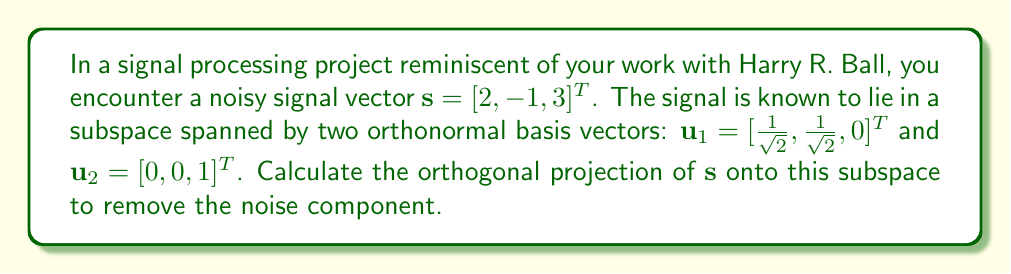Can you solve this math problem? To calculate the orthogonal projection of $\mathbf{s}$ onto the subspace spanned by $\mathbf{u}_1$ and $\mathbf{u}_2$, we'll follow these steps:

1) The projection matrix onto the subspace is given by:
   $$P = U(U^TU)^{-1}U^T$$
   where $U = [\mathbf{u}_1 \quad \mathbf{u}_2]$

2) Construct matrix $U$:
   $$U = \begin{bmatrix} 
   \frac{1}{\sqrt{2}} & 0 \\
   \frac{1}{\sqrt{2}} & 0 \\
   0 & 1
   \end{bmatrix}$$

3) Calculate $U^TU$:
   $$U^TU = \begin{bmatrix} 
   1 & 0 \\
   0 & 1
   \end{bmatrix}$$

4) As $U^TU$ is already the identity matrix, $(U^TU)^{-1} = I$

5) Calculate the projection matrix $P$:
   $$P = UU^T = \begin{bmatrix} 
   \frac{1}{2} & \frac{1}{2} & 0 \\
   \frac{1}{2} & \frac{1}{2} & 0 \\
   0 & 0 & 1
   \end{bmatrix}$$

6) The projection of $\mathbf{s}$ onto the subspace is:
   $$\mathbf{s}_{\text{proj}} = P\mathbf{s} = \begin{bmatrix} 
   \frac{1}{2} & \frac{1}{2} & 0 \\
   \frac{1}{2} & \frac{1}{2} & 0 \\
   0 & 0 & 1
   \end{bmatrix} \begin{bmatrix} 
   2 \\
   -1 \\
   3
   \end{bmatrix} = \begin{bmatrix} 
   \frac{1}{2} \\
   \frac{1}{2} \\
   3
   \end{bmatrix}$$

Therefore, the orthogonal projection of $\mathbf{s}$ onto the subspace is $[\frac{1}{2}, \frac{1}{2}, 3]^T$.
Answer: $[\frac{1}{2}, \frac{1}{2}, 3]^T$ 